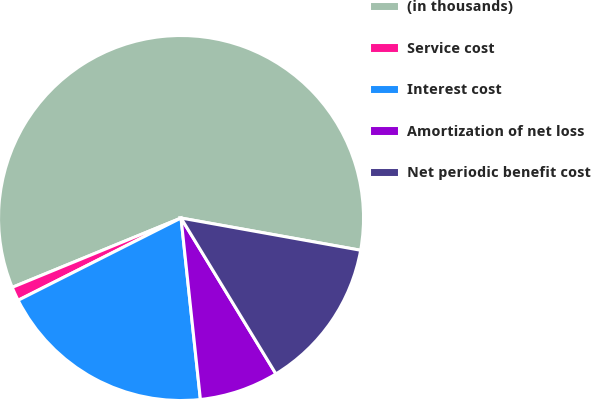Convert chart to OTSL. <chart><loc_0><loc_0><loc_500><loc_500><pie_chart><fcel>(in thousands)<fcel>Service cost<fcel>Interest cost<fcel>Amortization of net loss<fcel>Net periodic benefit cost<nl><fcel>59.03%<fcel>1.24%<fcel>19.25%<fcel>7.01%<fcel>13.47%<nl></chart> 